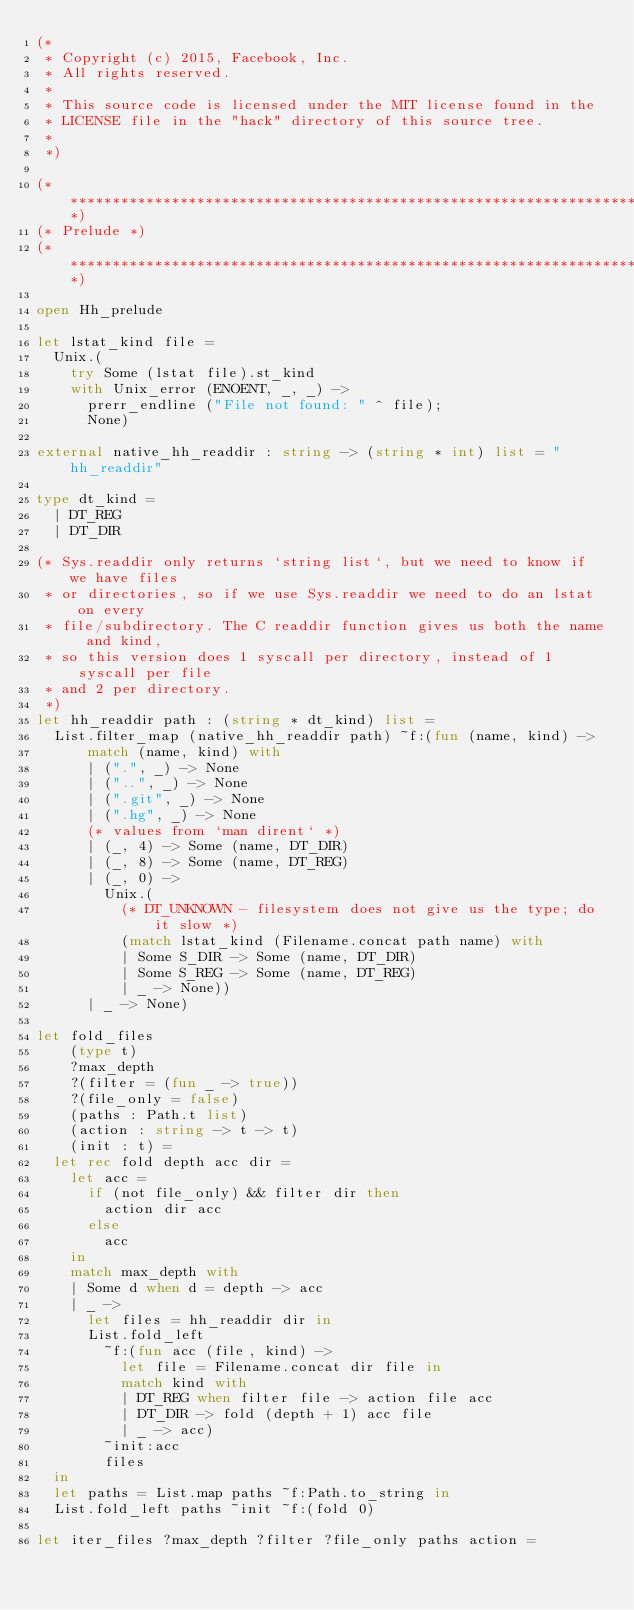<code> <loc_0><loc_0><loc_500><loc_500><_OCaml_>(*
 * Copyright (c) 2015, Facebook, Inc.
 * All rights reserved.
 *
 * This source code is licensed under the MIT license found in the
 * LICENSE file in the "hack" directory of this source tree.
 *
 *)

(*****************************************************************************)
(* Prelude *)
(*****************************************************************************)

open Hh_prelude

let lstat_kind file =
  Unix.(
    try Some (lstat file).st_kind
    with Unix_error (ENOENT, _, _) ->
      prerr_endline ("File not found: " ^ file);
      None)

external native_hh_readdir : string -> (string * int) list = "hh_readdir"

type dt_kind =
  | DT_REG
  | DT_DIR

(* Sys.readdir only returns `string list`, but we need to know if we have files
 * or directories, so if we use Sys.readdir we need to do an lstat on every
 * file/subdirectory. The C readdir function gives us both the name and kind,
 * so this version does 1 syscall per directory, instead of 1 syscall per file
 * and 2 per directory.
 *)
let hh_readdir path : (string * dt_kind) list =
  List.filter_map (native_hh_readdir path) ~f:(fun (name, kind) ->
      match (name, kind) with
      | (".", _) -> None
      | ("..", _) -> None
      | (".git", _) -> None
      | (".hg", _) -> None
      (* values from `man dirent` *)
      | (_, 4) -> Some (name, DT_DIR)
      | (_, 8) -> Some (name, DT_REG)
      | (_, 0) ->
        Unix.(
          (* DT_UNKNOWN - filesystem does not give us the type; do it slow *)
          (match lstat_kind (Filename.concat path name) with
          | Some S_DIR -> Some (name, DT_DIR)
          | Some S_REG -> Some (name, DT_REG)
          | _ -> None))
      | _ -> None)

let fold_files
    (type t)
    ?max_depth
    ?(filter = (fun _ -> true))
    ?(file_only = false)
    (paths : Path.t list)
    (action : string -> t -> t)
    (init : t) =
  let rec fold depth acc dir =
    let acc =
      if (not file_only) && filter dir then
        action dir acc
      else
        acc
    in
    match max_depth with
    | Some d when d = depth -> acc
    | _ ->
      let files = hh_readdir dir in
      List.fold_left
        ~f:(fun acc (file, kind) ->
          let file = Filename.concat dir file in
          match kind with
          | DT_REG when filter file -> action file acc
          | DT_DIR -> fold (depth + 1) acc file
          | _ -> acc)
        ~init:acc
        files
  in
  let paths = List.map paths ~f:Path.to_string in
  List.fold_left paths ~init ~f:(fold 0)

let iter_files ?max_depth ?filter ?file_only paths action =</code> 